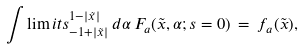Convert formula to latex. <formula><loc_0><loc_0><loc_500><loc_500>\int \lim i t s _ { - 1 + | \tilde { x } | } ^ { 1 - | \tilde { x } | } \, d \alpha \, F _ { a } ( \tilde { x } , \alpha ; s = 0 ) \, = \, f _ { a } ( \tilde { x } ) ,</formula> 